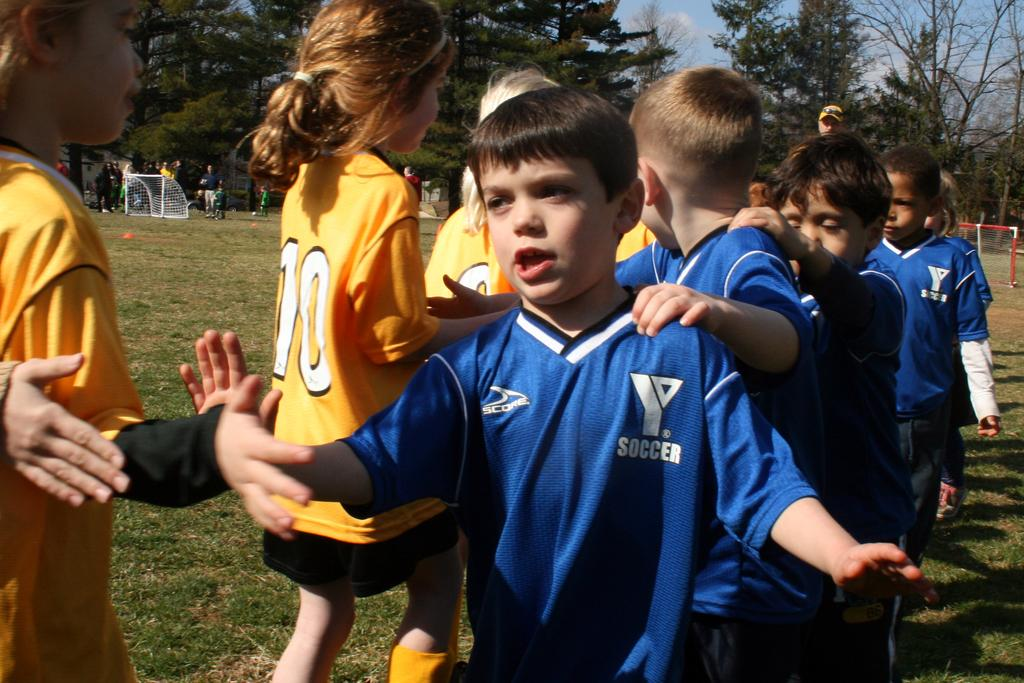Provide a one-sentence caption for the provided image. Two youth soccer teams are lined up to high five each other. 